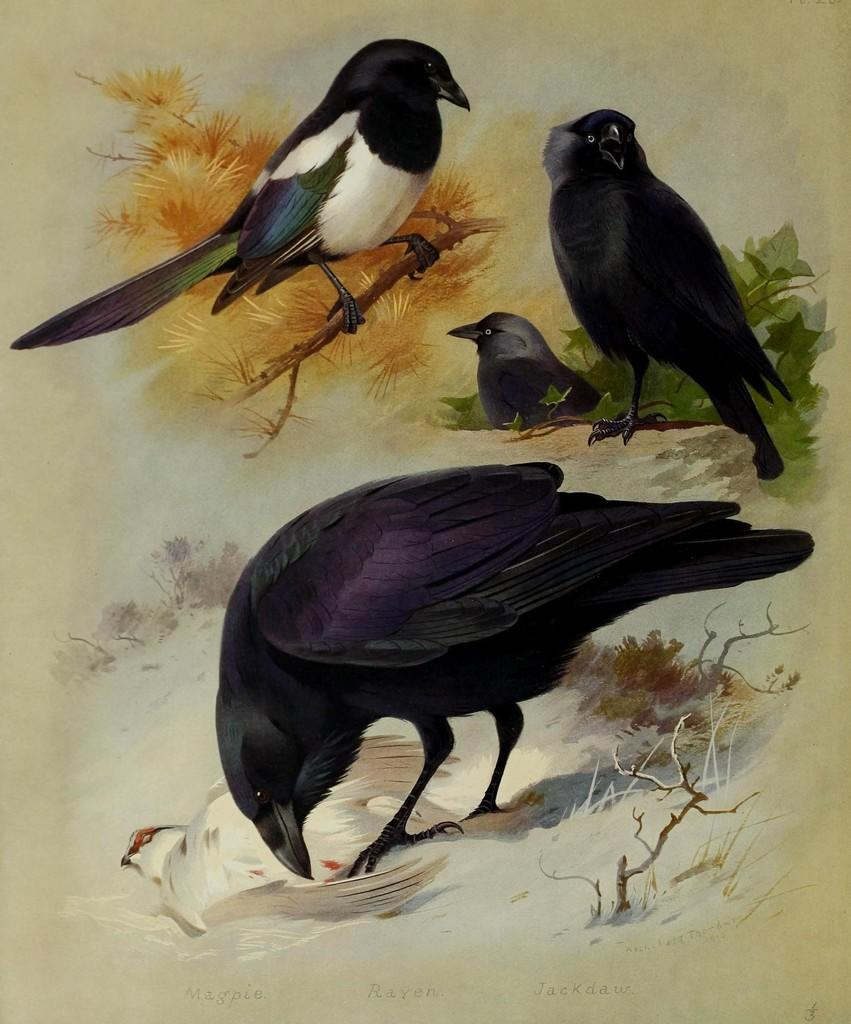What type of artwork is featured in the image? There are paintings in the image. What subject matter is depicted in the paintings? The paintings depict crows and another bird. Can you describe the scene involving the other bird? The bird is standing on the branch of a tree. What discovery was made by the crows in the image? There is no indication in the image that the crows made any discoveries. How does the power of the bird affect the tree branch it is standing on? The image does not show any indication of the bird's power affecting the tree branch. 